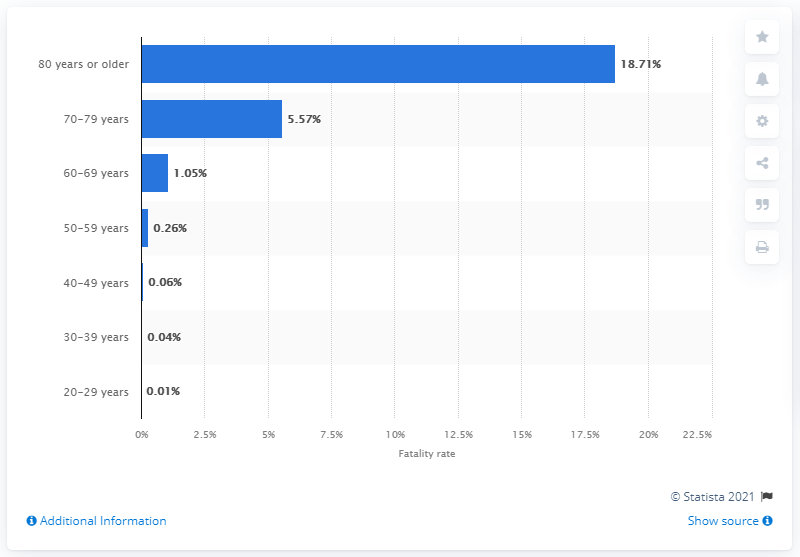Outline some significant characteristics in this image. According to data as of June 24, 2021, the age group with the highest fatality rate of COVID-19 in South Korea was individuals aged 80 years or older. 